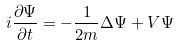<formula> <loc_0><loc_0><loc_500><loc_500>i \frac { \partial \Psi } { \partial t } = - \frac { 1 } { 2 m } \Delta \Psi + V \Psi</formula> 